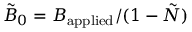Convert formula to latex. <formula><loc_0><loc_0><loc_500><loc_500>\tilde { B } _ { 0 } = B _ { a p p l i e d } / ( 1 - \tilde { N } )</formula> 